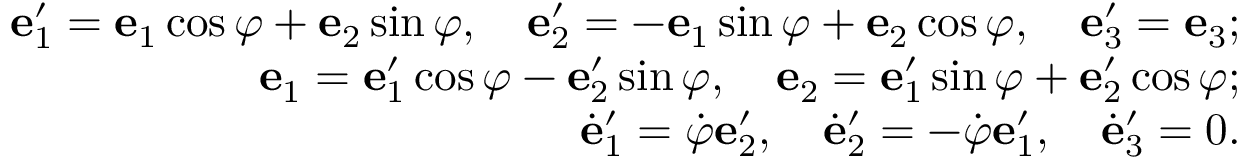<formula> <loc_0><loc_0><loc_500><loc_500>\begin{array} { r } { { e } _ { 1 } ^ { \prime } = { e } _ { 1 } \cos \varphi + { e } _ { 2 } \sin \varphi , \quad e _ { 2 } ^ { \prime } = - { e } _ { 1 } \sin \varphi + { e } _ { 2 } \cos \varphi , \quad e _ { 3 } ^ { \prime } = { e } _ { 3 } ; } \\ { { e } _ { 1 } = { e } _ { 1 } ^ { \prime } \cos \varphi - { e } _ { 2 } ^ { \prime } \sin \varphi , \quad e _ { 2 } = { e } _ { 1 } ^ { \prime } \sin \varphi + { e } _ { 2 } ^ { \prime } \cos \varphi ; } \\ { \dot { e } _ { 1 } ^ { \prime } = \dot { \varphi } { e } _ { 2 } ^ { \prime } , \quad \dot { e } _ { 2 } ^ { \prime } = - \dot { \varphi } { e } _ { 1 } ^ { \prime } , \quad \dot { e } _ { 3 } ^ { \prime } = 0 . } \end{array}</formula> 